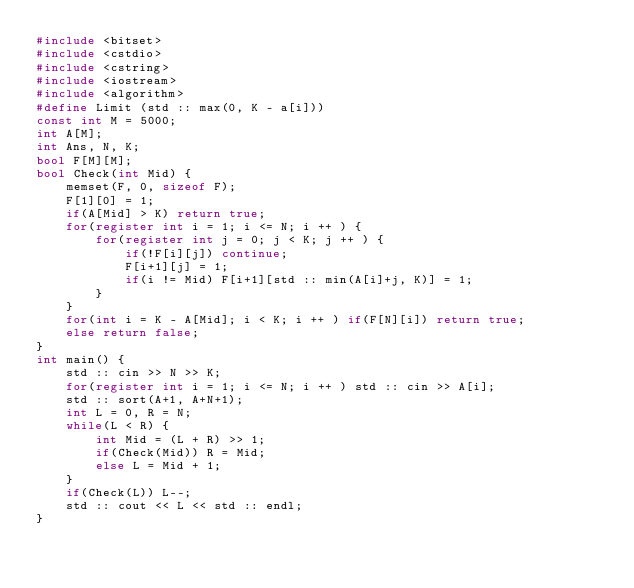<code> <loc_0><loc_0><loc_500><loc_500><_C++_>#include <bitset>
#include <cstdio>
#include <cstring>
#include <iostream>
#include <algorithm>
#define Limit (std :: max(0, K - a[i]))
const int M = 5000;
int A[M];
int Ans, N, K;
bool F[M][M];
bool Check(int Mid) {
	memset(F, 0, sizeof F);
	F[1][0] = 1;
	if(A[Mid] > K) return true;
	for(register int i = 1; i <= N; i ++ ) {
		for(register int j = 0; j < K; j ++ ) {
			if(!F[i][j]) continue;
			F[i+1][j] = 1;
			if(i != Mid) F[i+1][std :: min(A[i]+j, K)] = 1;
		}
	}
	for(int i = K - A[Mid]; i < K; i ++ ) if(F[N][i]) return true;
	else return false;
}
int main() {
	std :: cin >> N >> K;
	for(register int i = 1; i <= N; i ++ ) std :: cin >> A[i];
	std :: sort(A+1, A+N+1);
	int L = 0, R = N;
	while(L < R) {
		int Mid = (L + R) >> 1;
		if(Check(Mid)) R = Mid;
		else L = Mid + 1;
	}
	if(Check(L)) L--;
	std :: cout << L << std :: endl;
}
</code> 